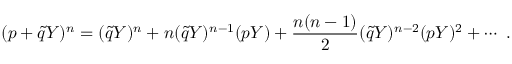Convert formula to latex. <formula><loc_0><loc_0><loc_500><loc_500>( p + \tilde { q } Y ) ^ { n } = ( \tilde { q } Y ) ^ { n } + n ( \tilde { q } Y ) ^ { n - 1 } ( p Y ) + \frac { n ( n - 1 ) } { 2 } ( \tilde { q } Y ) ^ { n - 2 } ( p Y ) ^ { 2 } + \cdots \ .</formula> 